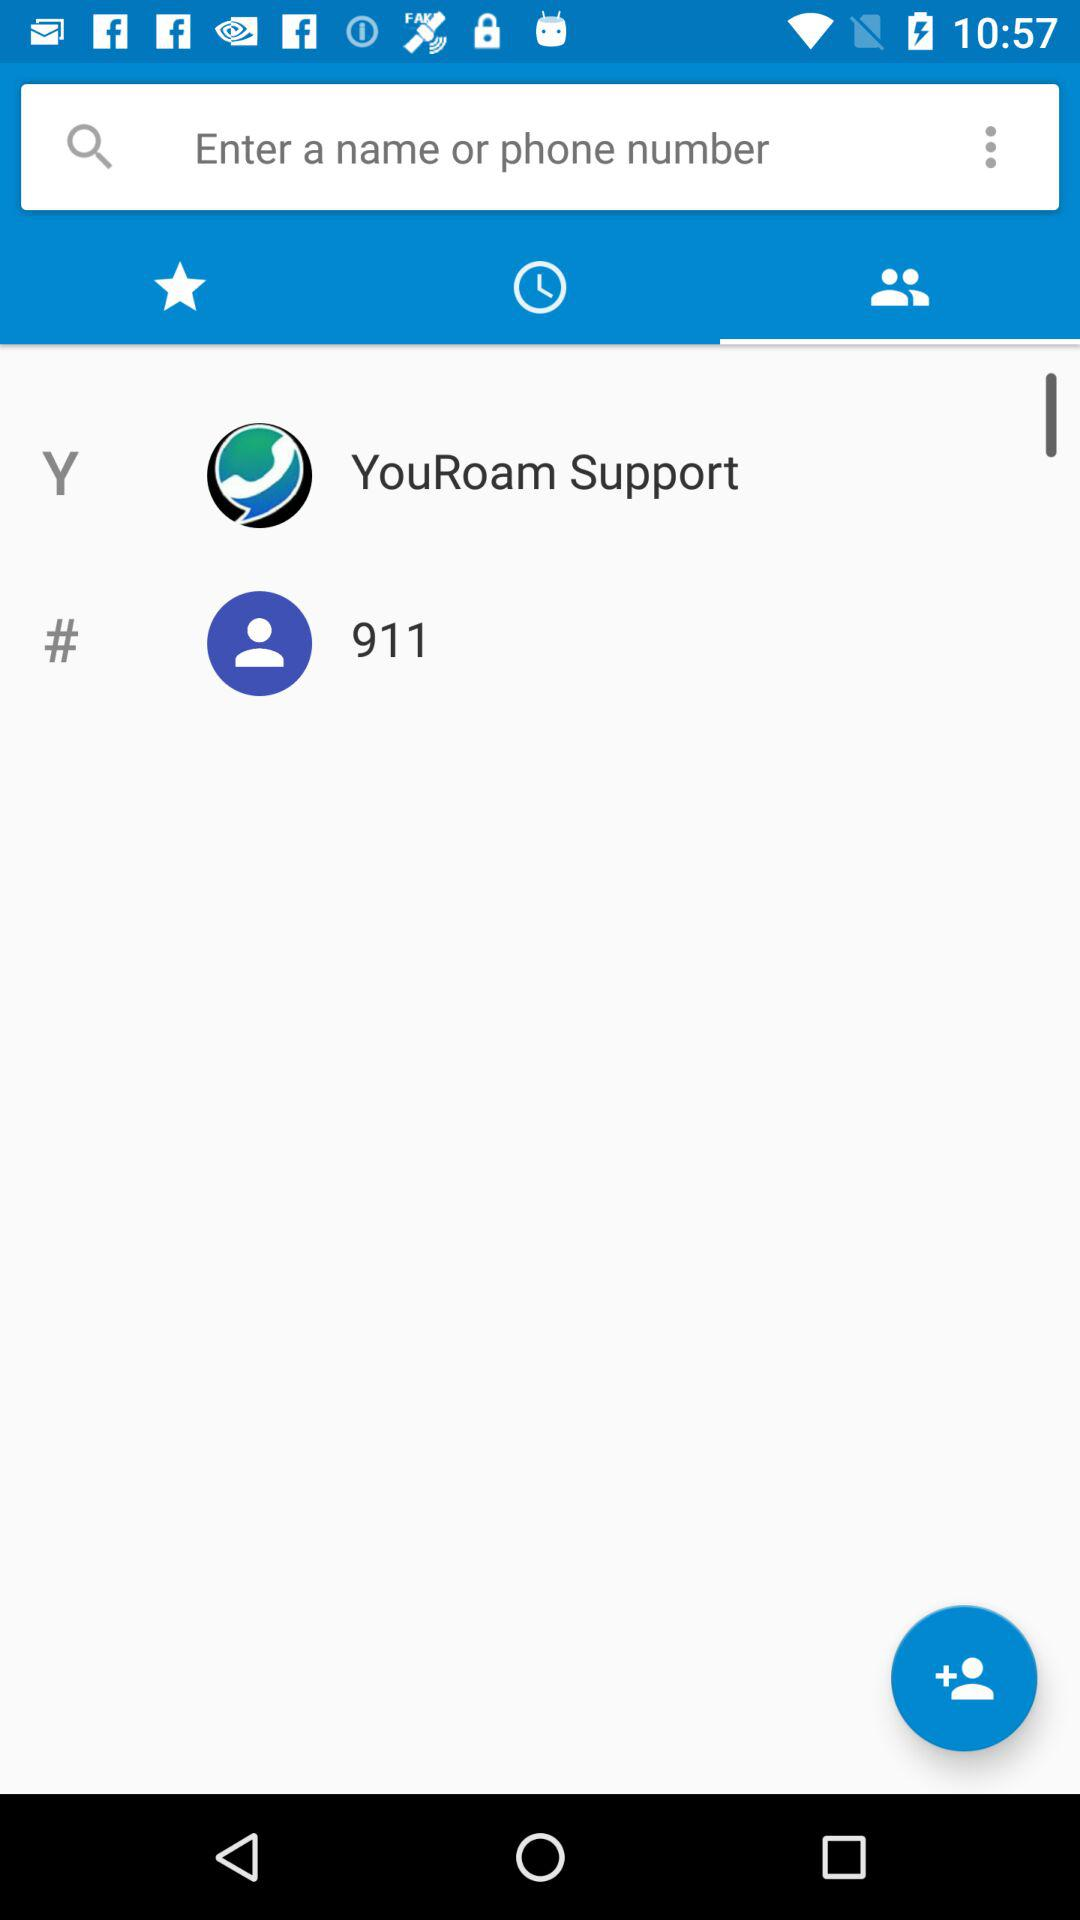What number has been given? The given number is 911. 